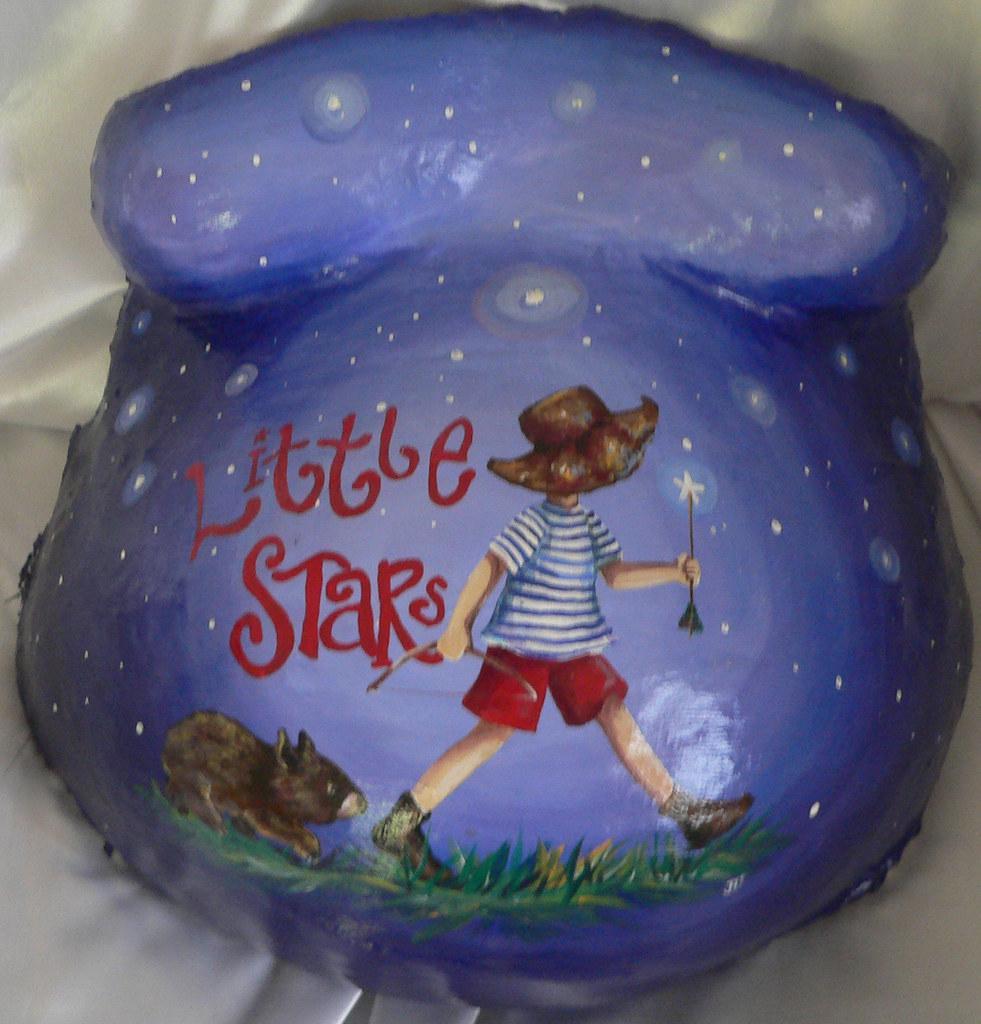Please provide a concise description of this image. In this picture there is an object. On the object, there is a painting of a boy walking and there is a painting of a rat and there is text and there is grass. At the top there is sky and there are stars. At the bottom there is a white color cloth. 